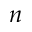<formula> <loc_0><loc_0><loc_500><loc_500>n</formula> 